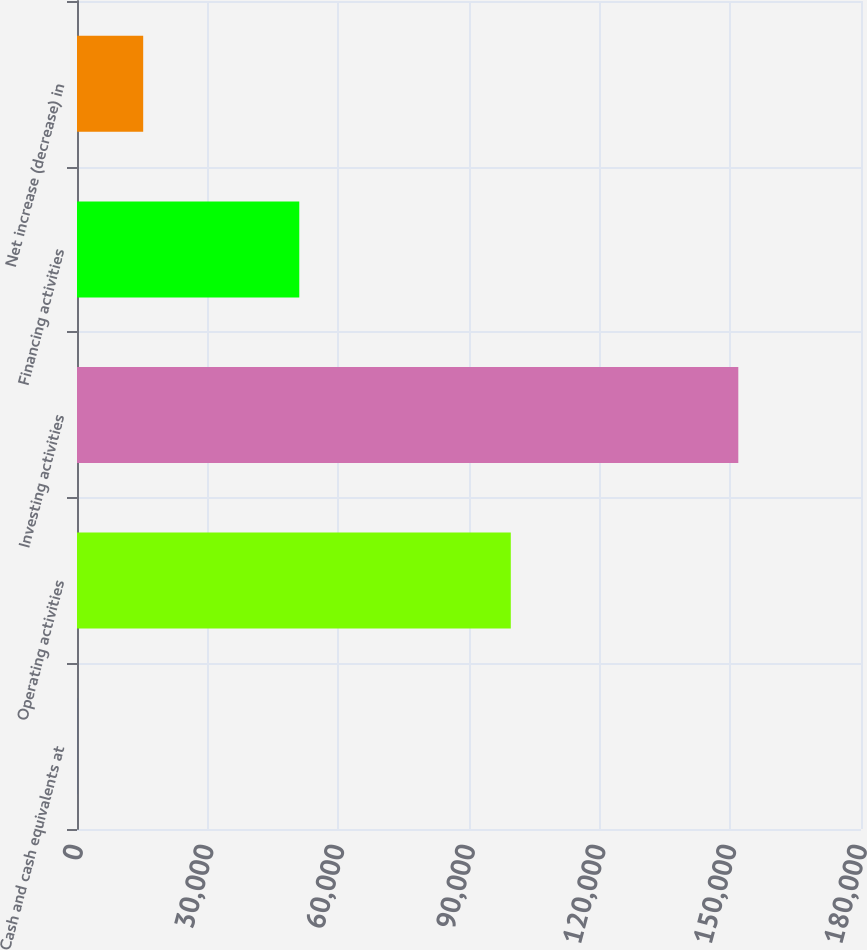Convert chart. <chart><loc_0><loc_0><loc_500><loc_500><bar_chart><fcel>Cash and cash equivalents at<fcel>Operating activities<fcel>Investing activities<fcel>Financing activities<fcel>Net increase (decrease) in<nl><fcel>16<fcel>99596<fcel>151830<fcel>51034<fcel>15197.4<nl></chart> 